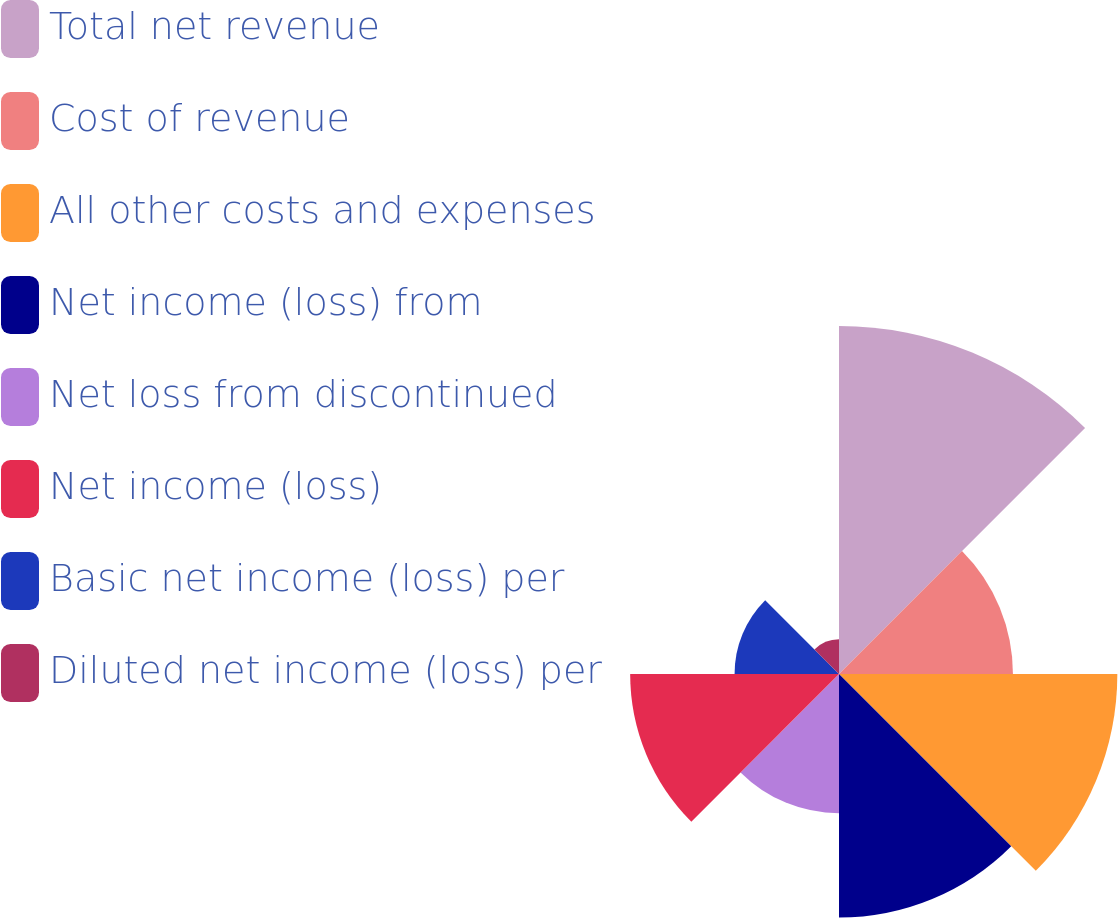<chart> <loc_0><loc_0><loc_500><loc_500><pie_chart><fcel>Total net revenue<fcel>Cost of revenue<fcel>All other costs and expenses<fcel>Net income (loss) from<fcel>Net loss from discontinued<fcel>Net income (loss)<fcel>Basic net income (loss) per<fcel>Diluted net income (loss) per<nl><fcel>22.73%<fcel>11.36%<fcel>18.18%<fcel>15.91%<fcel>9.09%<fcel>13.64%<fcel>6.82%<fcel>2.27%<nl></chart> 